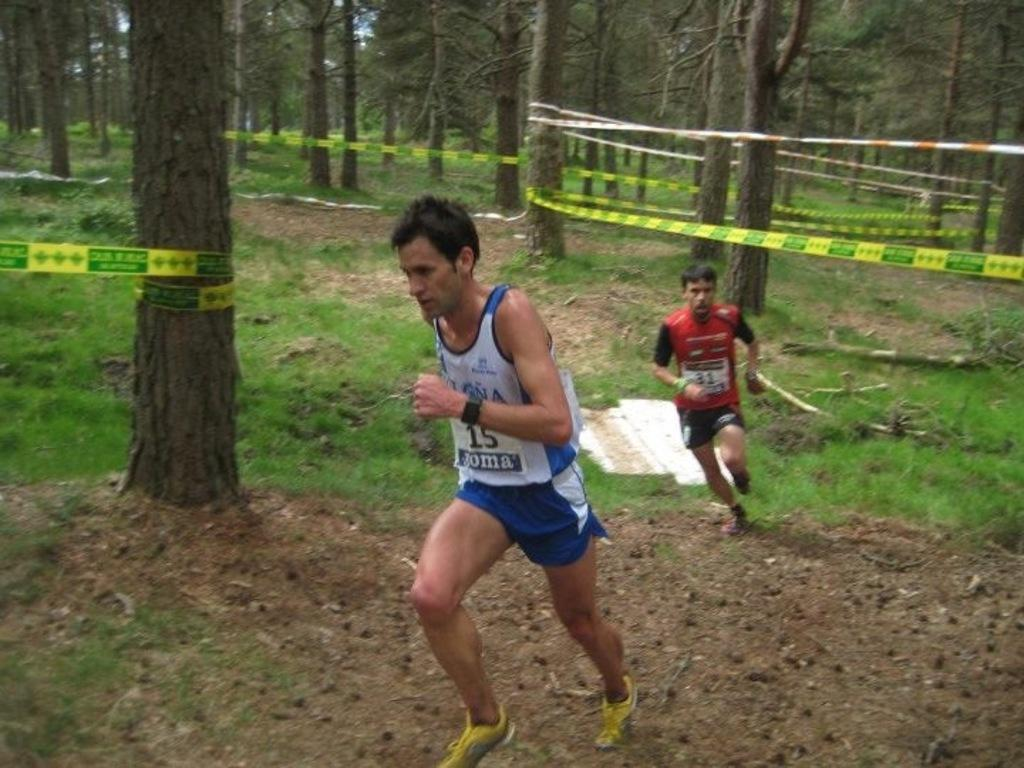How many people are in the image? There are two persons in the image. What are the persons wearing? The persons are wearing chest numbers. What are the persons doing in the image? The persons are running. What is the ground surface like in the image? There is grass on the ground in the image. What can be seen in the background of the image? There are trees in the image. What is tied between the trees? Something is tied between the trees, but we cannot determine what it is from the given facts. What type of bit is being used by the horses in the image? There are no horses or bits present in the image; it features two persons running with chest numbers. 